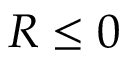<formula> <loc_0><loc_0><loc_500><loc_500>R \leq 0</formula> 